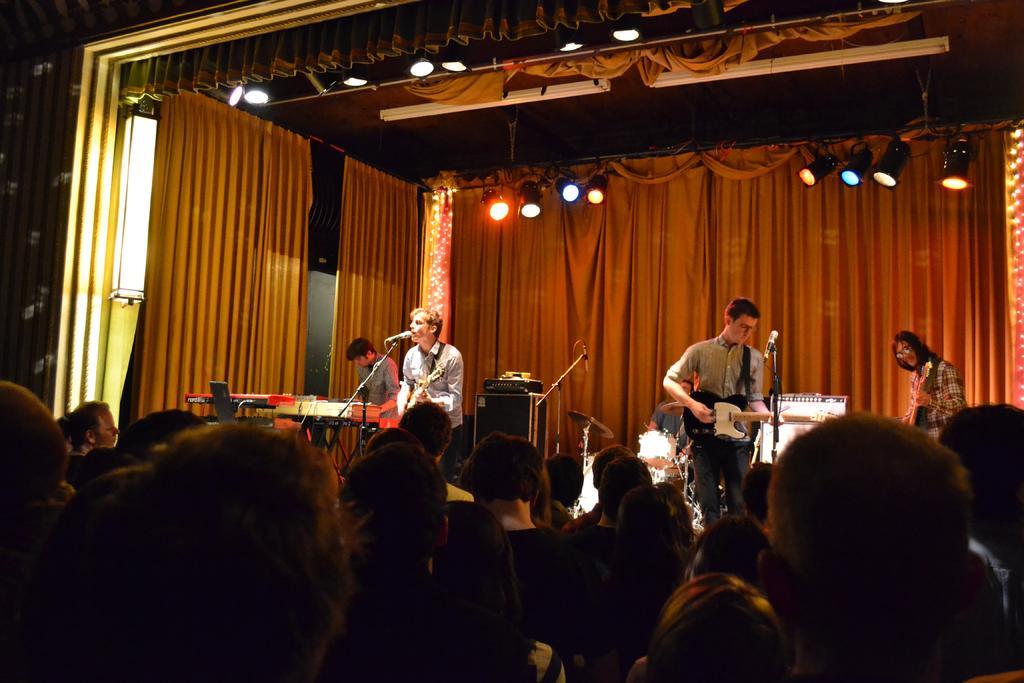Describe this image in one or two sentences. In this picture we can see two persons are standing on the stage and playing guitar. And these are the people who are listening to them. And in the background there is a curtain and these are the lights. 